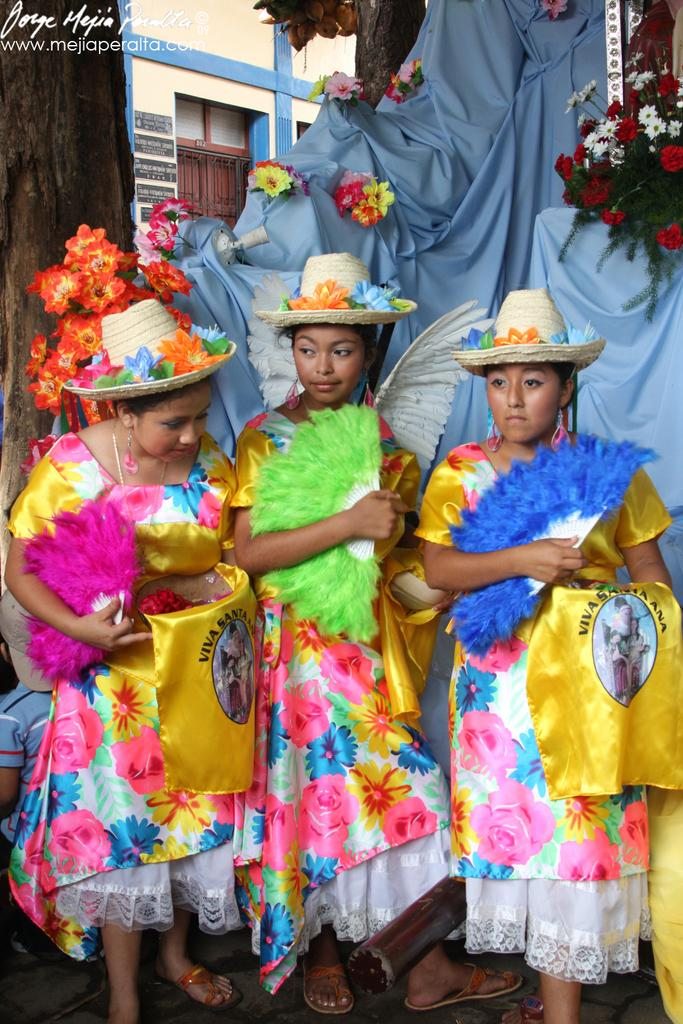How many women are in the image? There are three women in the image. What are the women wearing on their heads? The women are wearing hats. What color are the dresses the women are wearing? The women are wearing yellow dresses. What can be seen in the background of the image? There is a cloth, a plant with flowers, a building, and a door in the background of the image. How much was the payment for the office space in the image? There is no mention of an office or payment in the image; it features three women wearing hats and yellow dresses, along with various background elements. 